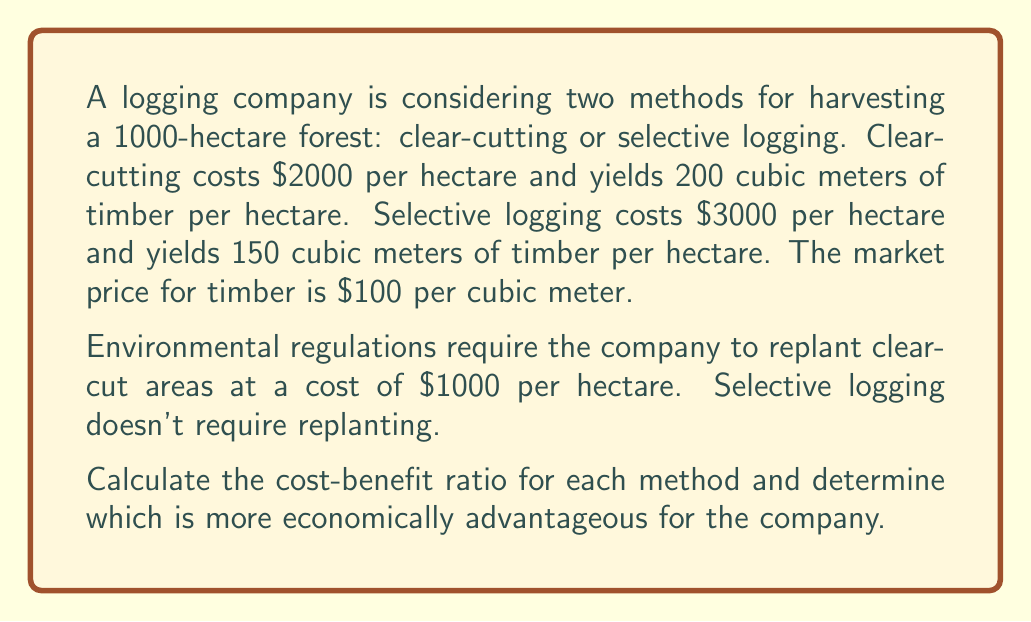Show me your answer to this math problem. Let's break this down step-by-step:

1) Clear-cutting method:
   a) Cost per hectare = $2000 (harvesting) + $1000 (replanting) = $3000
   b) Revenue per hectare = 200 cubic meters × $100/cubic meter = $20,000
   c) Profit per hectare = $20,000 - $3000 = $17,000
   d) Total profit for 1000 hectares = $17,000 × 1000 = $17,000,000
   e) Cost-benefit ratio = Revenue / Cost = $20,000,000 / $3,000,000 = 6.67

2) Selective logging method:
   a) Cost per hectare = $3000
   b) Revenue per hectare = 150 cubic meters × $100/cubic meter = $15,000
   c) Profit per hectare = $15,000 - $3000 = $12,000
   d) Total profit for 1000 hectares = $12,000 × 1000 = $12,000,000
   e) Cost-benefit ratio = Revenue / Cost = $15,000,000 / $3,000,000 = 5

3) Comparing the cost-benefit ratios:
   Clear-cutting: 6.67
   Selective logging: 5

The cost-benefit ratio is higher for clear-cutting, indicating it's more economically advantageous for the company.

To verify, we can compare the total profits:
Clear-cutting: $17,000,000
Selective logging: $12,000,000

This confirms that clear-cutting is more profitable in this scenario.
Answer: Clear-cutting with a cost-benefit ratio of 6.67 